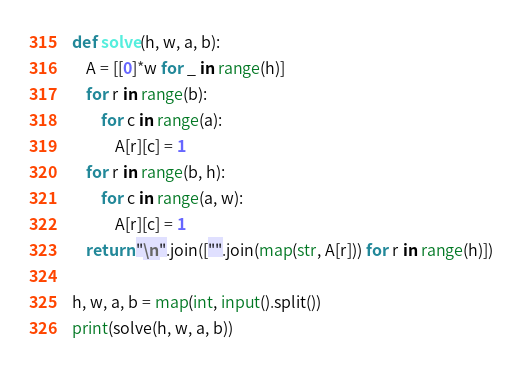Convert code to text. <code><loc_0><loc_0><loc_500><loc_500><_Python_>def solve(h, w, a, b):
    A = [[0]*w for _ in range(h)]
    for r in range(b):
        for c in range(a):
            A[r][c] = 1
    for r in range(b, h):
        for c in range(a, w):
            A[r][c] = 1
    return "\n".join(["".join(map(str, A[r])) for r in range(h)])

h, w, a, b = map(int, input().split())
print(solve(h, w, a, b))</code> 